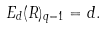<formula> <loc_0><loc_0><loc_500><loc_500>E _ { d } ( R ) _ { q = 1 } = d .</formula> 